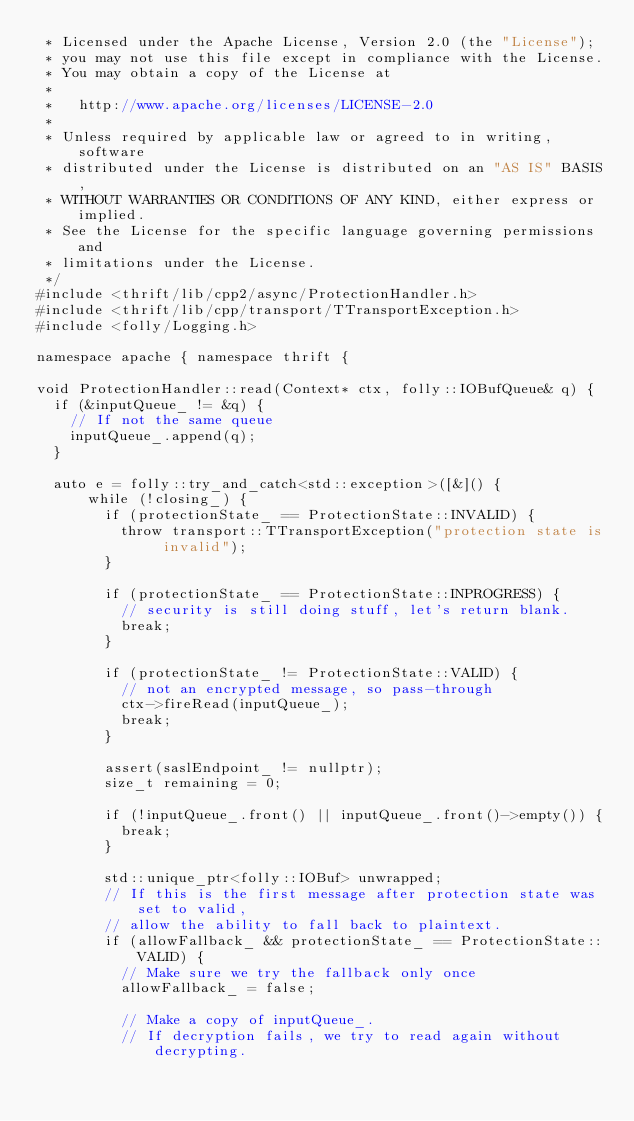Convert code to text. <code><loc_0><loc_0><loc_500><loc_500><_C++_> * Licensed under the Apache License, Version 2.0 (the "License");
 * you may not use this file except in compliance with the License.
 * You may obtain a copy of the License at
 *
 *   http://www.apache.org/licenses/LICENSE-2.0
 *
 * Unless required by applicable law or agreed to in writing, software
 * distributed under the License is distributed on an "AS IS" BASIS,
 * WITHOUT WARRANTIES OR CONDITIONS OF ANY KIND, either express or implied.
 * See the License for the specific language governing permissions and
 * limitations under the License.
 */
#include <thrift/lib/cpp2/async/ProtectionHandler.h>
#include <thrift/lib/cpp/transport/TTransportException.h>
#include <folly/Logging.h>

namespace apache { namespace thrift {

void ProtectionHandler::read(Context* ctx, folly::IOBufQueue& q) {
  if (&inputQueue_ != &q) {
    // If not the same queue
    inputQueue_.append(q);
  }

  auto e = folly::try_and_catch<std::exception>([&]() {
      while (!closing_) {
        if (protectionState_ == ProtectionState::INVALID) {
          throw transport::TTransportException("protection state is invalid");
        }

        if (protectionState_ == ProtectionState::INPROGRESS) {
          // security is still doing stuff, let's return blank.
          break;
        }

        if (protectionState_ != ProtectionState::VALID) {
          // not an encrypted message, so pass-through
          ctx->fireRead(inputQueue_);
          break;
        }

        assert(saslEndpoint_ != nullptr);
        size_t remaining = 0;

        if (!inputQueue_.front() || inputQueue_.front()->empty()) {
          break;
        }

        std::unique_ptr<folly::IOBuf> unwrapped;
        // If this is the first message after protection state was set to valid,
        // allow the ability to fall back to plaintext.
        if (allowFallback_ && protectionState_ == ProtectionState::VALID) {
          // Make sure we try the fallback only once
          allowFallback_ = false;

          // Make a copy of inputQueue_.
          // If decryption fails, we try to read again without decrypting.</code> 